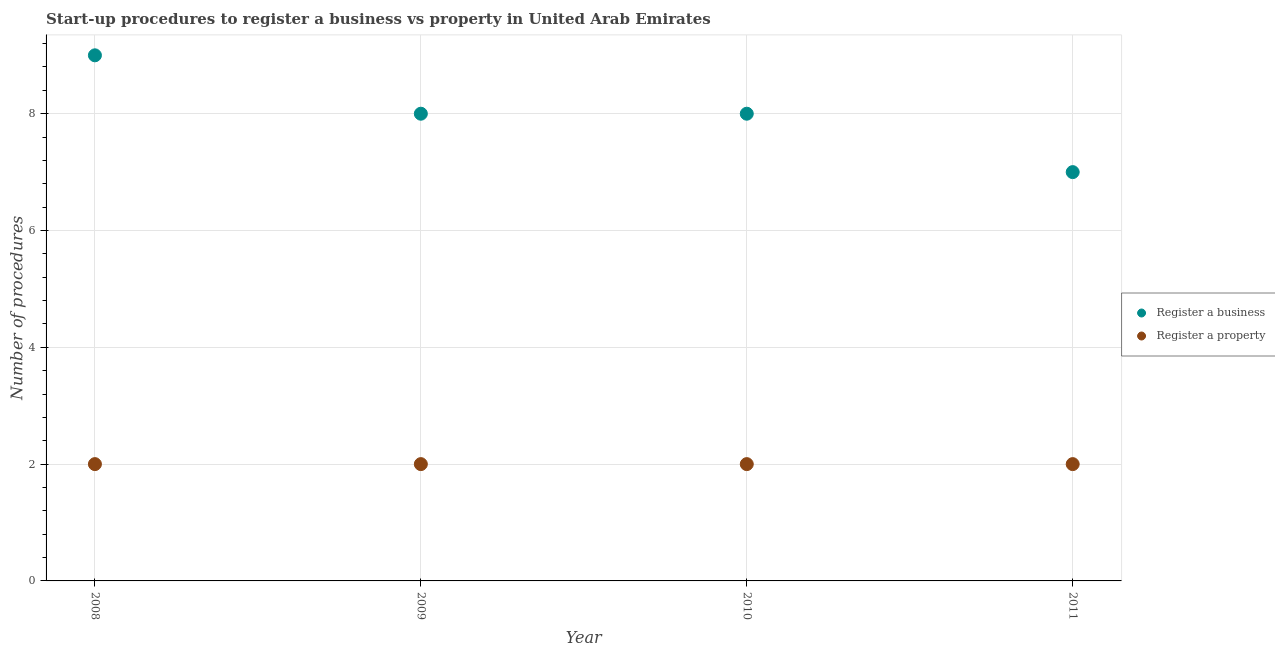What is the number of procedures to register a property in 2008?
Offer a very short reply. 2. Across all years, what is the maximum number of procedures to register a property?
Your answer should be very brief. 2. Across all years, what is the minimum number of procedures to register a business?
Your answer should be compact. 7. In which year was the number of procedures to register a business maximum?
Ensure brevity in your answer.  2008. What is the total number of procedures to register a property in the graph?
Offer a terse response. 8. What is the difference between the number of procedures to register a property in 2009 and that in 2010?
Keep it short and to the point. 0. What is the difference between the number of procedures to register a property in 2011 and the number of procedures to register a business in 2009?
Keep it short and to the point. -6. What is the average number of procedures to register a property per year?
Keep it short and to the point. 2. In the year 2008, what is the difference between the number of procedures to register a property and number of procedures to register a business?
Offer a very short reply. -7. In how many years, is the number of procedures to register a business greater than 4.4?
Keep it short and to the point. 4. Is the difference between the number of procedures to register a property in 2008 and 2009 greater than the difference between the number of procedures to register a business in 2008 and 2009?
Offer a terse response. No. What is the difference between the highest and the lowest number of procedures to register a property?
Your answer should be very brief. 0. How many years are there in the graph?
Make the answer very short. 4. What is the difference between two consecutive major ticks on the Y-axis?
Your answer should be compact. 2. Are the values on the major ticks of Y-axis written in scientific E-notation?
Provide a short and direct response. No. Does the graph contain any zero values?
Provide a short and direct response. No. Does the graph contain grids?
Ensure brevity in your answer.  Yes. What is the title of the graph?
Keep it short and to the point. Start-up procedures to register a business vs property in United Arab Emirates. Does "Goods" appear as one of the legend labels in the graph?
Give a very brief answer. No. What is the label or title of the X-axis?
Your answer should be very brief. Year. What is the label or title of the Y-axis?
Make the answer very short. Number of procedures. What is the Number of procedures of Register a property in 2009?
Provide a short and direct response. 2. What is the Number of procedures of Register a business in 2010?
Your response must be concise. 8. What is the Number of procedures of Register a property in 2010?
Provide a succinct answer. 2. Across all years, what is the maximum Number of procedures in Register a property?
Offer a terse response. 2. Across all years, what is the minimum Number of procedures of Register a business?
Offer a terse response. 7. What is the total Number of procedures in Register a business in the graph?
Keep it short and to the point. 32. What is the total Number of procedures of Register a property in the graph?
Offer a terse response. 8. What is the difference between the Number of procedures in Register a property in 2008 and that in 2009?
Make the answer very short. 0. What is the difference between the Number of procedures of Register a business in 2008 and that in 2010?
Make the answer very short. 1. What is the difference between the Number of procedures of Register a business in 2008 and that in 2011?
Provide a succinct answer. 2. What is the difference between the Number of procedures in Register a property in 2008 and that in 2011?
Make the answer very short. 0. What is the difference between the Number of procedures in Register a business in 2009 and that in 2010?
Keep it short and to the point. 0. What is the difference between the Number of procedures in Register a property in 2009 and that in 2010?
Make the answer very short. 0. What is the difference between the Number of procedures in Register a property in 2009 and that in 2011?
Offer a very short reply. 0. What is the difference between the Number of procedures of Register a business in 2008 and the Number of procedures of Register a property in 2009?
Your response must be concise. 7. What is the difference between the Number of procedures in Register a business in 2008 and the Number of procedures in Register a property in 2010?
Ensure brevity in your answer.  7. What is the difference between the Number of procedures in Register a business in 2008 and the Number of procedures in Register a property in 2011?
Your answer should be very brief. 7. What is the difference between the Number of procedures of Register a business in 2009 and the Number of procedures of Register a property in 2011?
Offer a very short reply. 6. What is the average Number of procedures of Register a business per year?
Your answer should be very brief. 8. What is the average Number of procedures in Register a property per year?
Keep it short and to the point. 2. In the year 2009, what is the difference between the Number of procedures of Register a business and Number of procedures of Register a property?
Offer a very short reply. 6. In the year 2011, what is the difference between the Number of procedures of Register a business and Number of procedures of Register a property?
Provide a short and direct response. 5. What is the ratio of the Number of procedures of Register a business in 2008 to that in 2009?
Offer a very short reply. 1.12. What is the ratio of the Number of procedures in Register a business in 2008 to that in 2010?
Ensure brevity in your answer.  1.12. What is the ratio of the Number of procedures of Register a property in 2008 to that in 2010?
Keep it short and to the point. 1. What is the ratio of the Number of procedures of Register a property in 2008 to that in 2011?
Give a very brief answer. 1. What is the ratio of the Number of procedures of Register a property in 2009 to that in 2010?
Make the answer very short. 1. What is the ratio of the Number of procedures in Register a business in 2009 to that in 2011?
Make the answer very short. 1.14. What is the ratio of the Number of procedures of Register a property in 2010 to that in 2011?
Offer a very short reply. 1. What is the difference between the highest and the second highest Number of procedures of Register a property?
Give a very brief answer. 0. What is the difference between the highest and the lowest Number of procedures in Register a business?
Your answer should be very brief. 2. What is the difference between the highest and the lowest Number of procedures of Register a property?
Give a very brief answer. 0. 